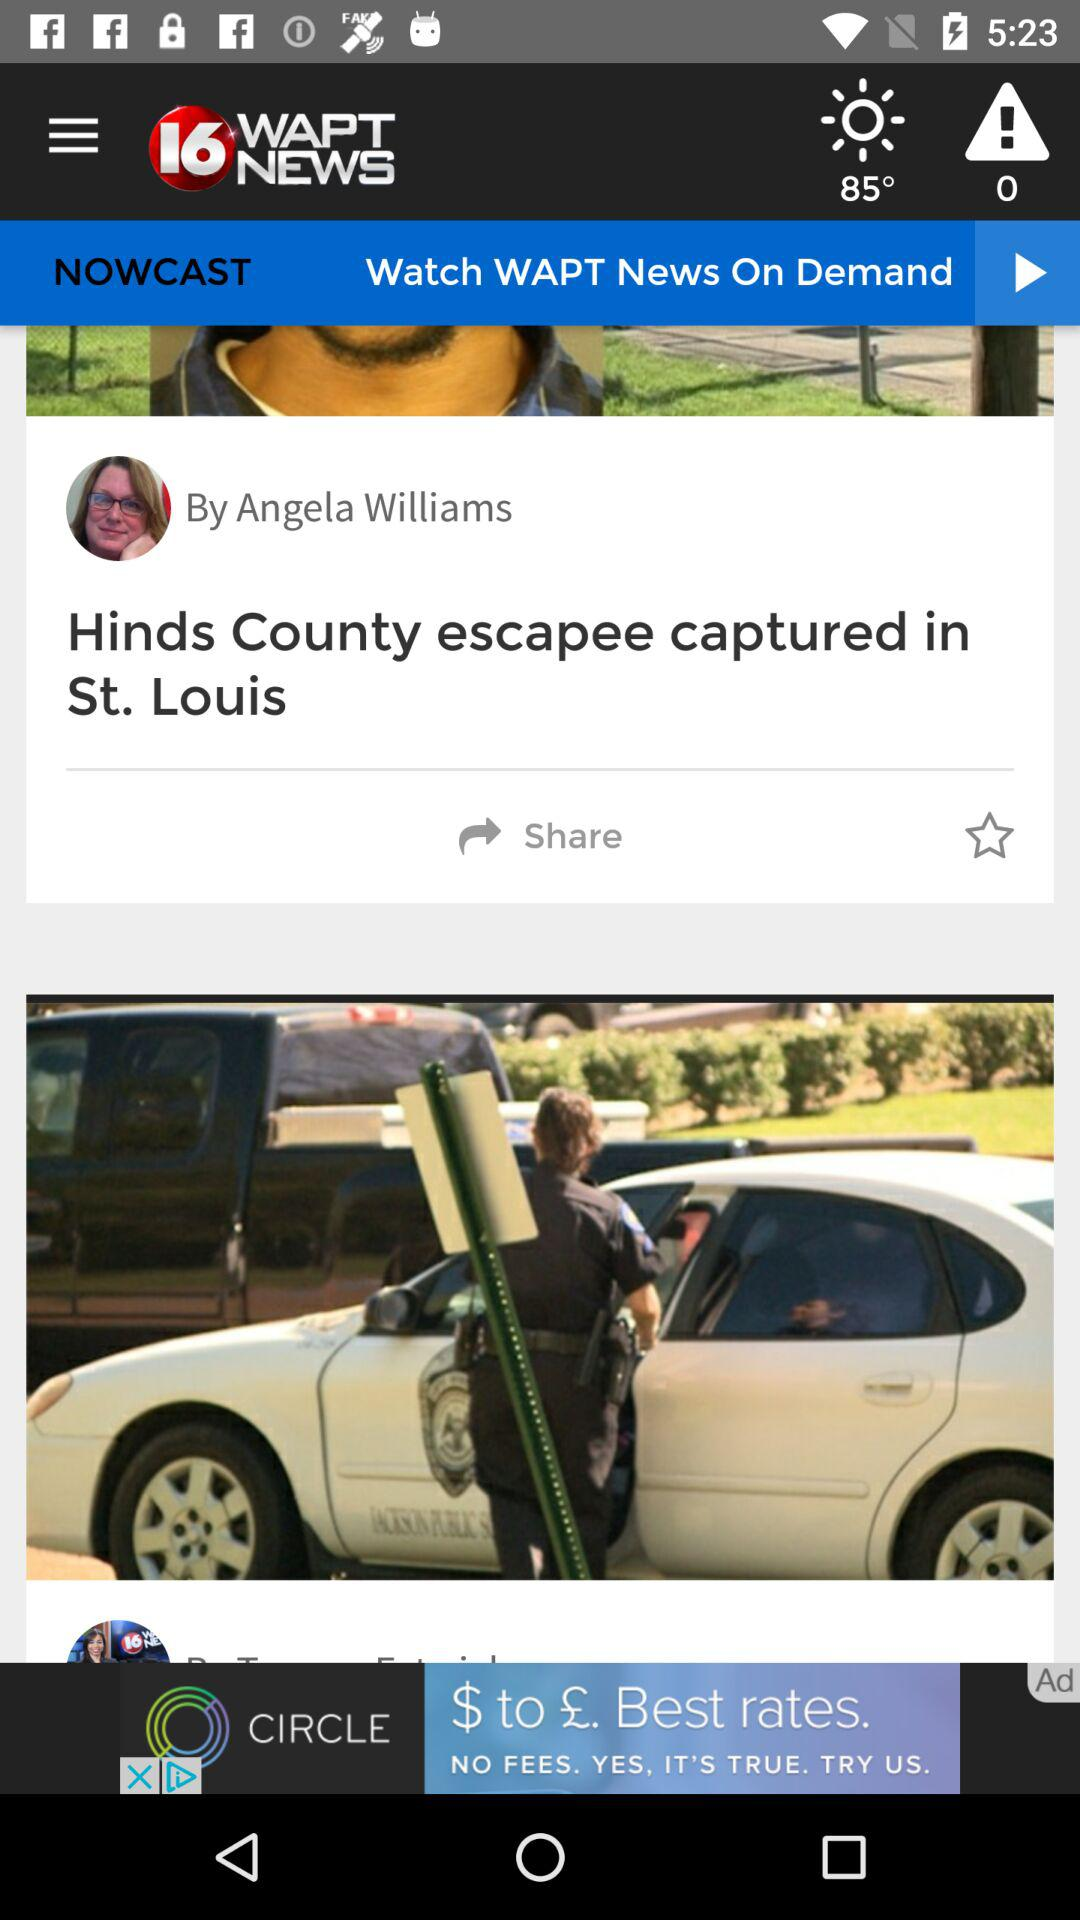What is the temperature shown on the screen? The shown temperature is 85°. 